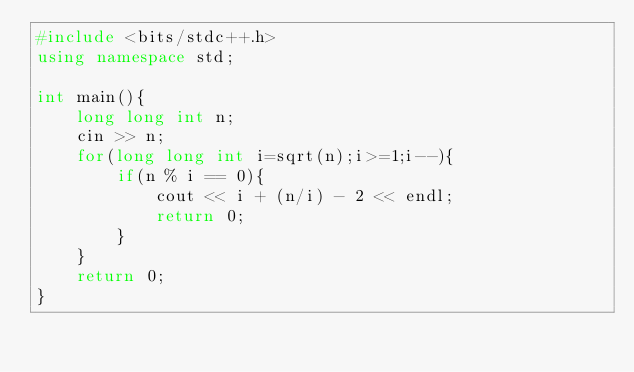<code> <loc_0><loc_0><loc_500><loc_500><_C++_>#include <bits/stdc++.h>
using namespace std;

int main(){
    long long int n;
    cin >> n;
    for(long long int i=sqrt(n);i>=1;i--){
        if(n % i == 0){
            cout << i + (n/i) - 2 << endl;
            return 0;
        }
    }
    return 0;
}</code> 